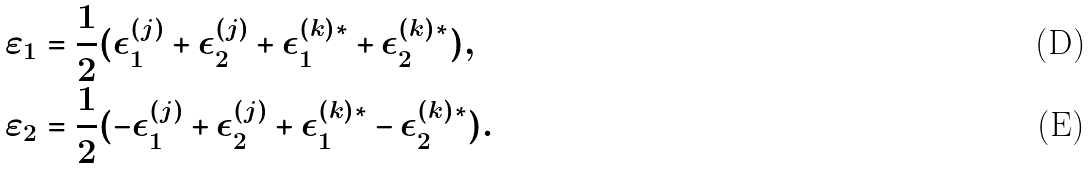Convert formula to latex. <formula><loc_0><loc_0><loc_500><loc_500>\varepsilon _ { 1 } & = \frac { 1 } { 2 } ( \epsilon _ { 1 } ^ { ( j ) } + \epsilon _ { 2 } ^ { ( j ) } + \epsilon _ { 1 } ^ { ( k ) * } + \epsilon _ { 2 } ^ { ( k ) * } ) , \\ \varepsilon _ { 2 } & = \frac { 1 } { 2 } ( - \epsilon _ { 1 } ^ { ( j ) } + \epsilon _ { 2 } ^ { ( j ) } + \epsilon _ { 1 } ^ { ( k ) * } - \epsilon _ { 2 } ^ { ( k ) * } ) .</formula> 